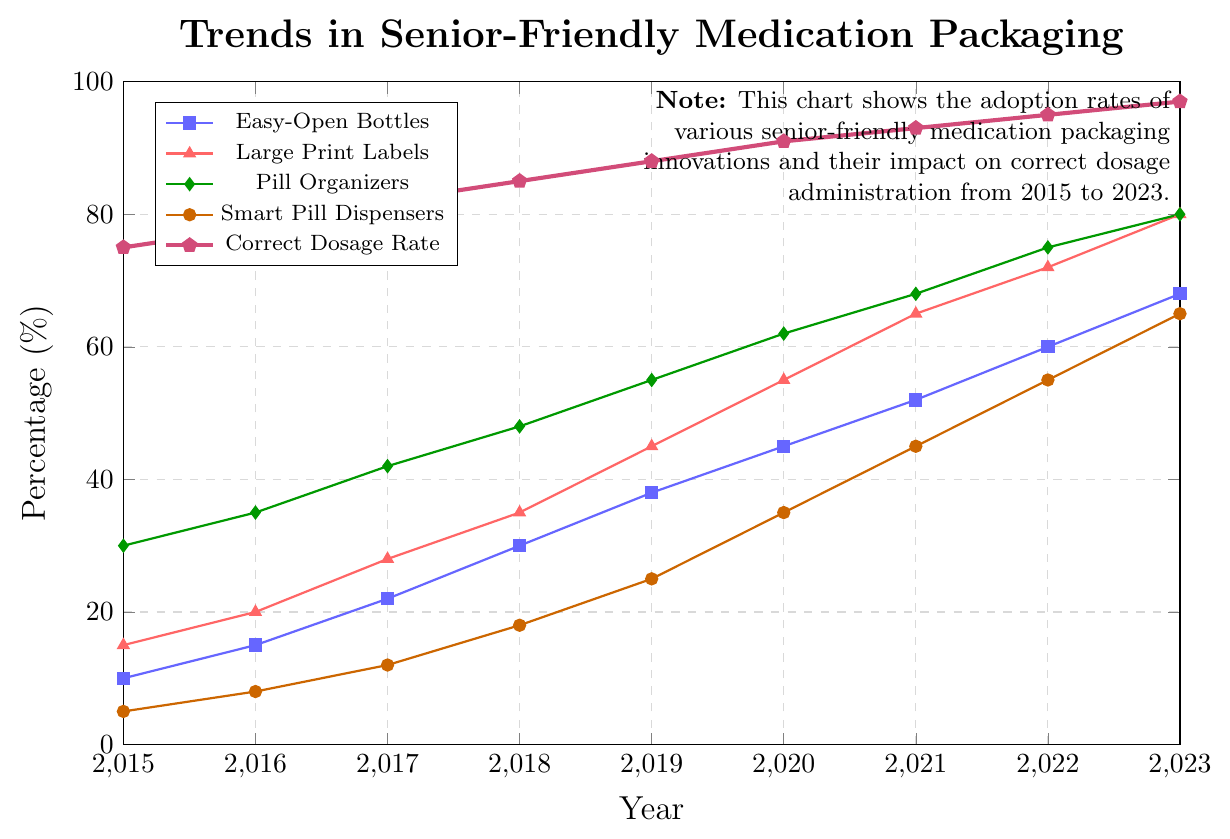What trends do you see in the adoption of Pill Organizers from 2015 to 2023? The percentages of Pill Organizers have been increasing steadily each year. Starting from 30% in 2015, they reached 80% by 2023, showing a continuous upward trend.
Answer: Continuous upward trend How much did the adoption rate of Smart Pill Dispensers increase from 2015 to 2023? In 2015, the adoption rate for Smart Pill Dispensers was 5%, and by 2023, it increased to 65%. The increase is calculated as 65% - 5% = 60%.
Answer: 60% In which year did the Correct Dosage Rate reach 90% or higher? By looking at the Correct Dosage Rate line, we see that it reached 91% in 2020, which is the first year it went above 90%.
Answer: 2020 Which innovation had the highest adoption rate in 2023? The adoption rates in 2023 are 68% for Easy-Open Bottles, 80% for Large Print Labels, 80% for Pill Organizers, 65% for Smart Pill Dispensers, and 97% for Correct Dosage Rate. Thus, the Correct Dosage Rate was the highest.
Answer: Correct Dosage Rate What was the adoption rate difference between Large Print Labels and Easy-Open Bottles in 2019? In 2019, the adoption rate for Large Print Labels was 45%, and for Easy-Open Bottles, it was 38%. The difference is 45% - 38% = 7%.
Answer: 7% Which type of senior-friendly medication packaging had the slowest increase in adoption rate from 2015 to 2023? By comparing the increases, Easy-Open Bottles increased from 10% to 68% (58%), Large Print Labels from 15% to 80% (65%), Pill Organizers from 30% to 80% (50%), and Smart Pill Dispensers from 5% to 65% (60%). Hence, Pill Organizers had the slowest increase of 50%.
Answer: Pill Organizers What is the sum of the adoption rates of all innovations in 2023? In 2023, the adoption rates are 68% (Easy-Open Bottles), 80% (Large Print Labels), 80% (Pill Organizers), and 65% (Smart Pill Dispensers). The sum is 68% + 80% + 80% + 65% = 293%.
Answer: 293% How did the Correct Dosage Rate change annually between 2015 and 2023? Analyzing each year: it changes from 75% (2015) to 78% (2016), 82% (2017), 85% (2018), 88% (2019), 91% (2020), 93% (2021), 95% (2022), and 97% (2023). It shows a steady annual increase over the years.
Answer: Steady annual increase 